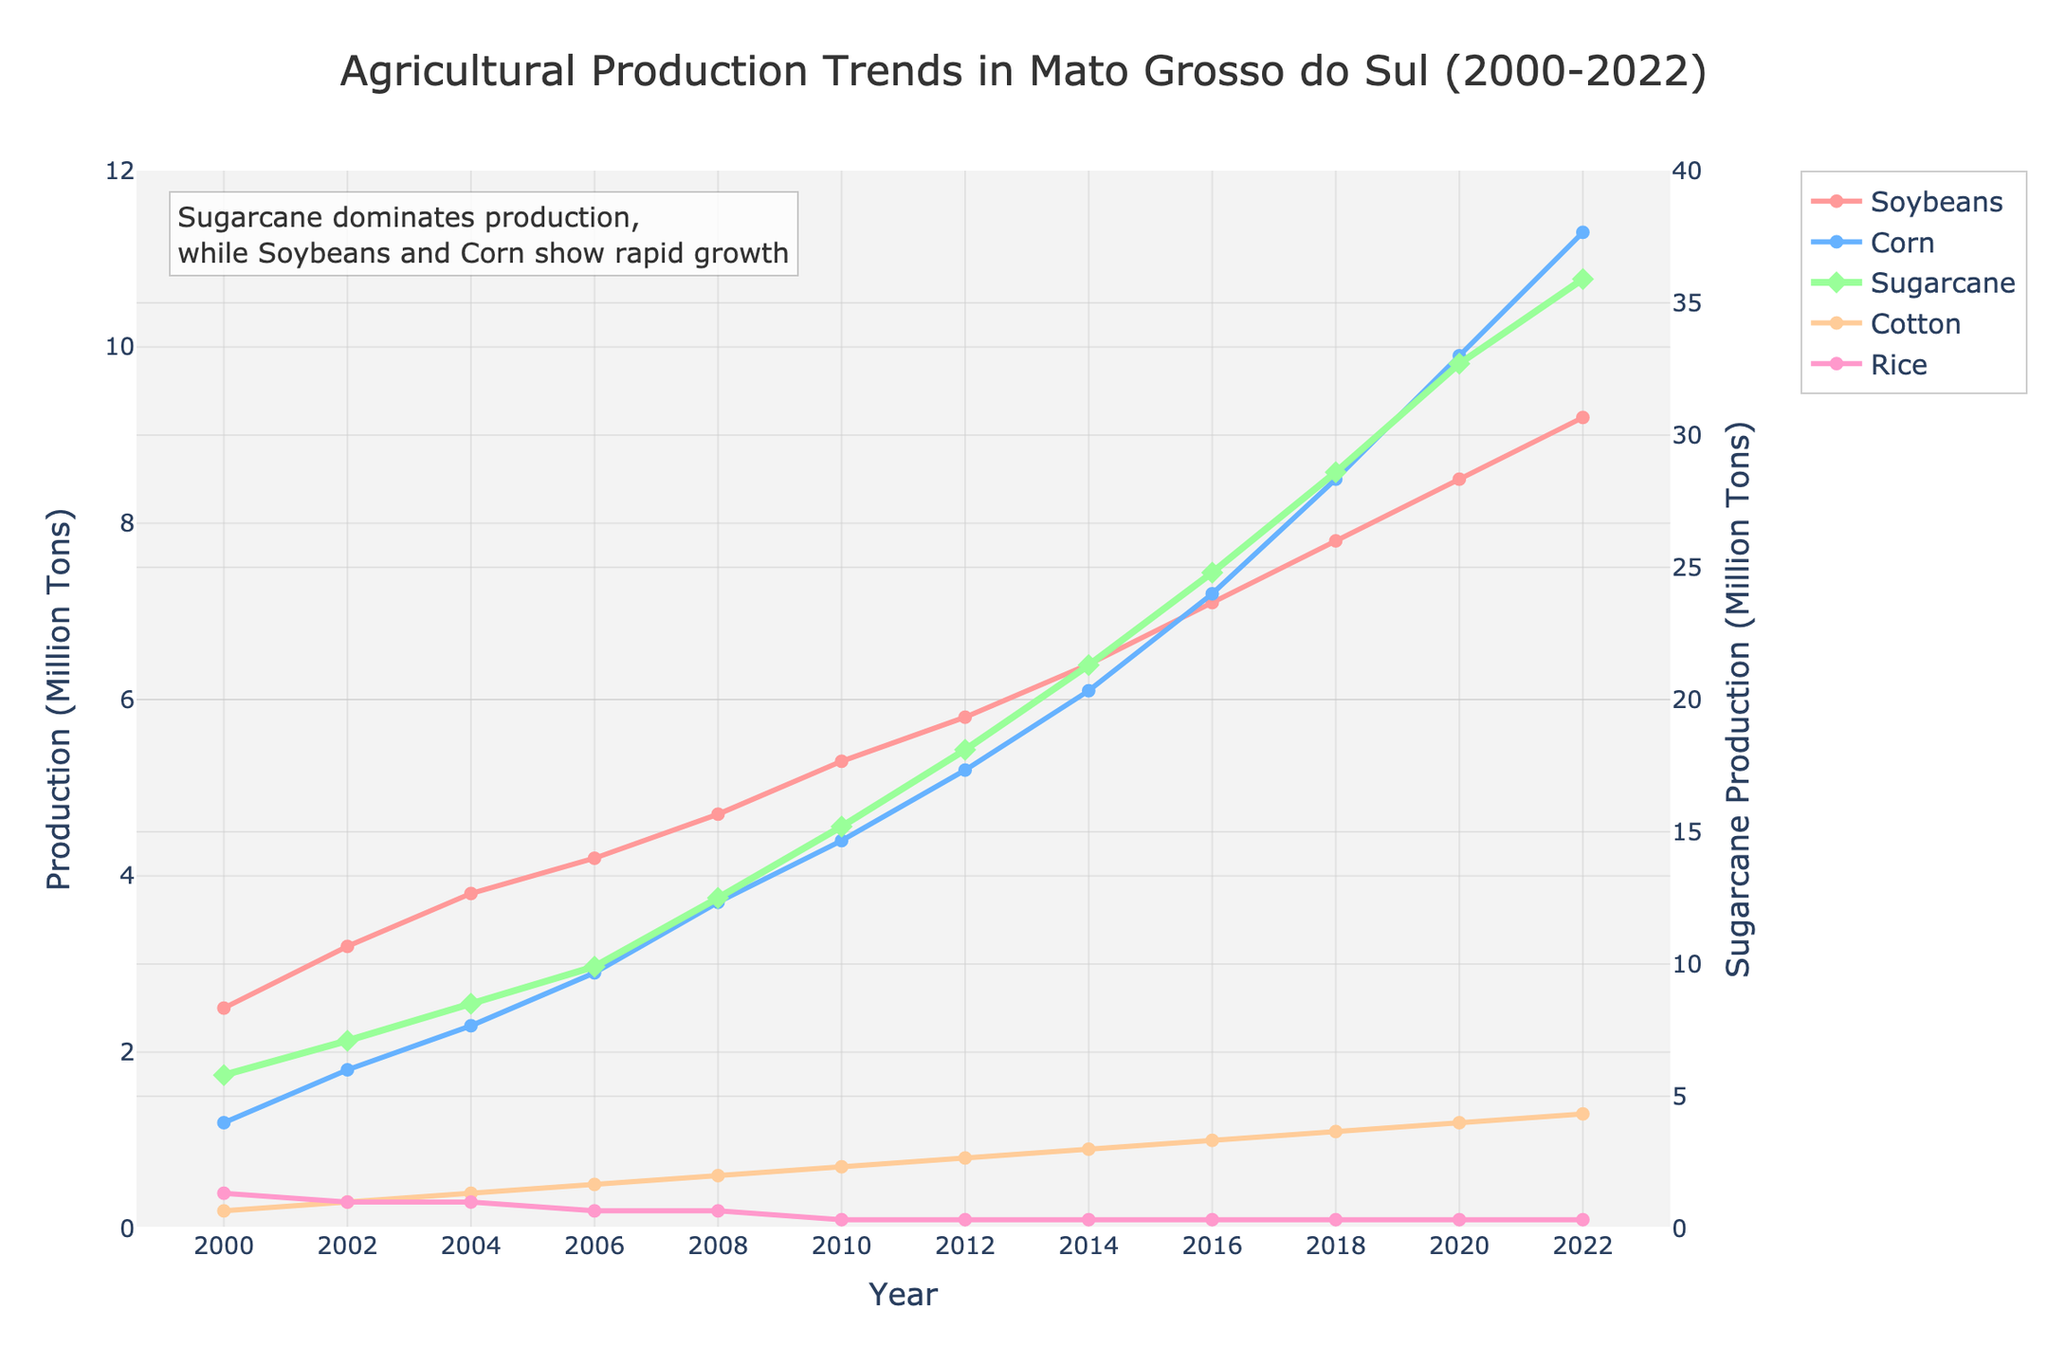What is the overall trend in soybean production from 2000 to 2022? By examining the line representing soybean production, we can see it starts at 2.5 million tons in 2000 and steadily increases to 9.2 million tons by 2022. This indicates a consistent upward trend over the 22-year period.
Answer: Consistent upward trend Which crop shows the fastest growth in production from 2000 to 2022? To determine the fastest growth, we need to compare the slopes of the lines for each crop. Sugarcane production starts at 5.8 million tons in 2000 and increases to 35.9 million tons in 2022, showing the steepest increase among all crops.
Answer: Sugarcane How does the production of corn in 2010 compare to soybeans in the same year? In the year 2010, corn production is represented by the data point at 4.4 million tons, whereas soybean production is at 5.3 million tons. Comparing these values shows that soybean production is higher than corn production in 2010.
Answer: Soybeans are higher than corn In which year did soybean production first exceed 5 million tons? The year when soybean production first exceeds 5 million tons can be identified by looking at the trend in the figure. Soybean production reaches 5.3 million tons in 2010, thus 2010 is the year it first exceeds 5 million tons.
Answer: 2010 What is the difference in production between sugarcane and corn in 2020? In 2020, sugarcane production is at 32.7 million tons and corn production is at 9.9 million tons. The difference is 32.7 - 9.9 = 22.8 million tons.
Answer: 22.8 million tons Which crops have shown a decline in production over the years? By examining the figure, we can see that all the crops except rice show increasing trends. Rice production declines from 0.4 million tons in 2000 to 0.1 million tons in 2022.
Answer: Rice Between 2004 and 2014, by how much did cotton production increase? Cotton production in 2004 is 0.4 million tons and increases to 0.9 million tons in 2014. The increase over this period is 0.9 - 0.4 = 0.5 million tons.
Answer: 0.5 million tons What is the production ratio of corn to soybeans in 2008? Corn production in 2008 is 3.7 million tons, and soybean production is 4.7 million tons. The ratio of corn to soybeans is 3.7 / 4.7, which simplifies to approximately 0.79.
Answer: 0.79 Which crop has the least production in any given year after 2010? The crop with the least production in any given year after 2010 can be identified by comparing the lines. Rice consistently has the least production, with values at or below 0.1 million tons each year.
Answer: Rice 